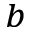<formula> <loc_0><loc_0><loc_500><loc_500>^ { b }</formula> 